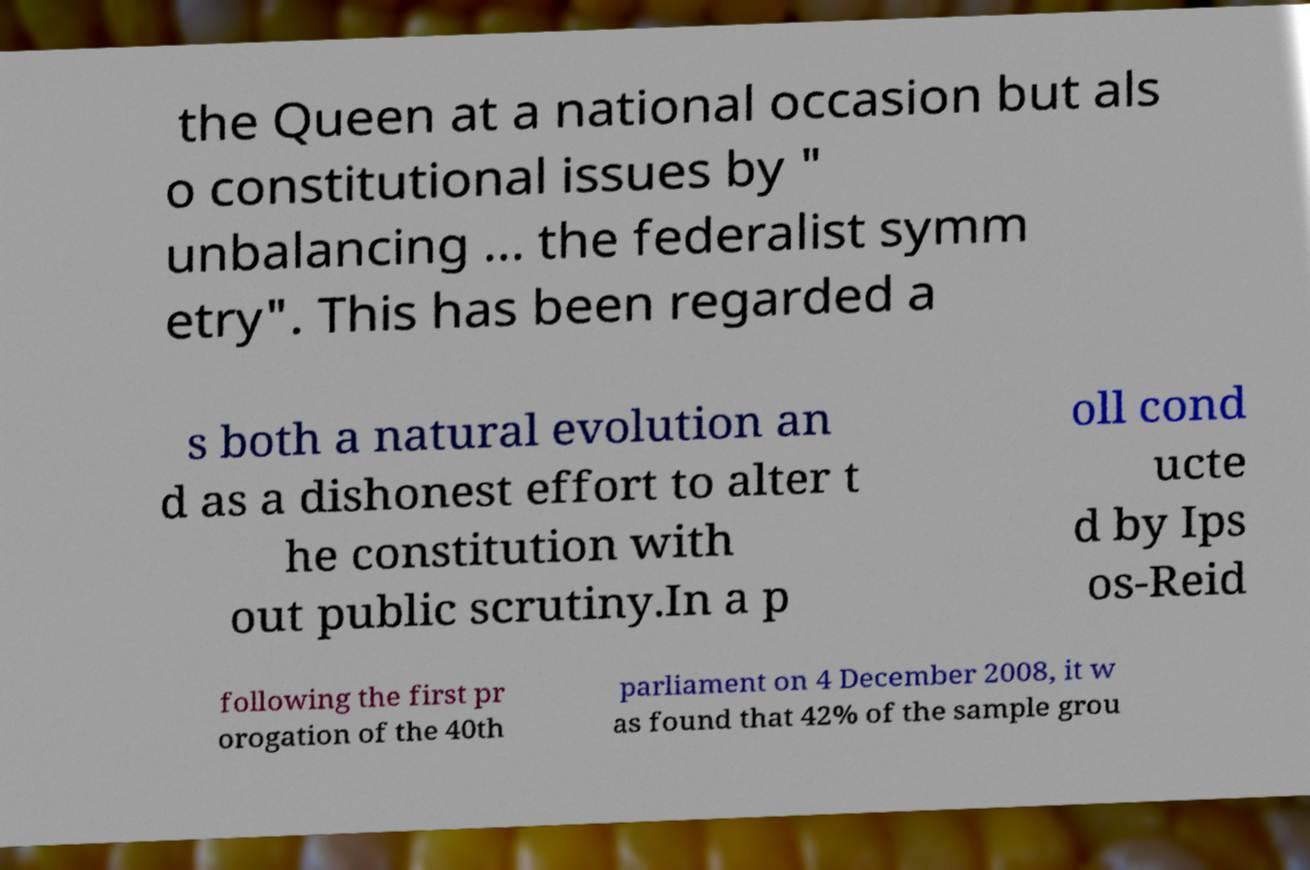Can you read and provide the text displayed in the image?This photo seems to have some interesting text. Can you extract and type it out for me? the Queen at a national occasion but als o constitutional issues by " unbalancing ... the federalist symm etry". This has been regarded a s both a natural evolution an d as a dishonest effort to alter t he constitution with out public scrutiny.In a p oll cond ucte d by Ips os-Reid following the first pr orogation of the 40th parliament on 4 December 2008, it w as found that 42% of the sample grou 